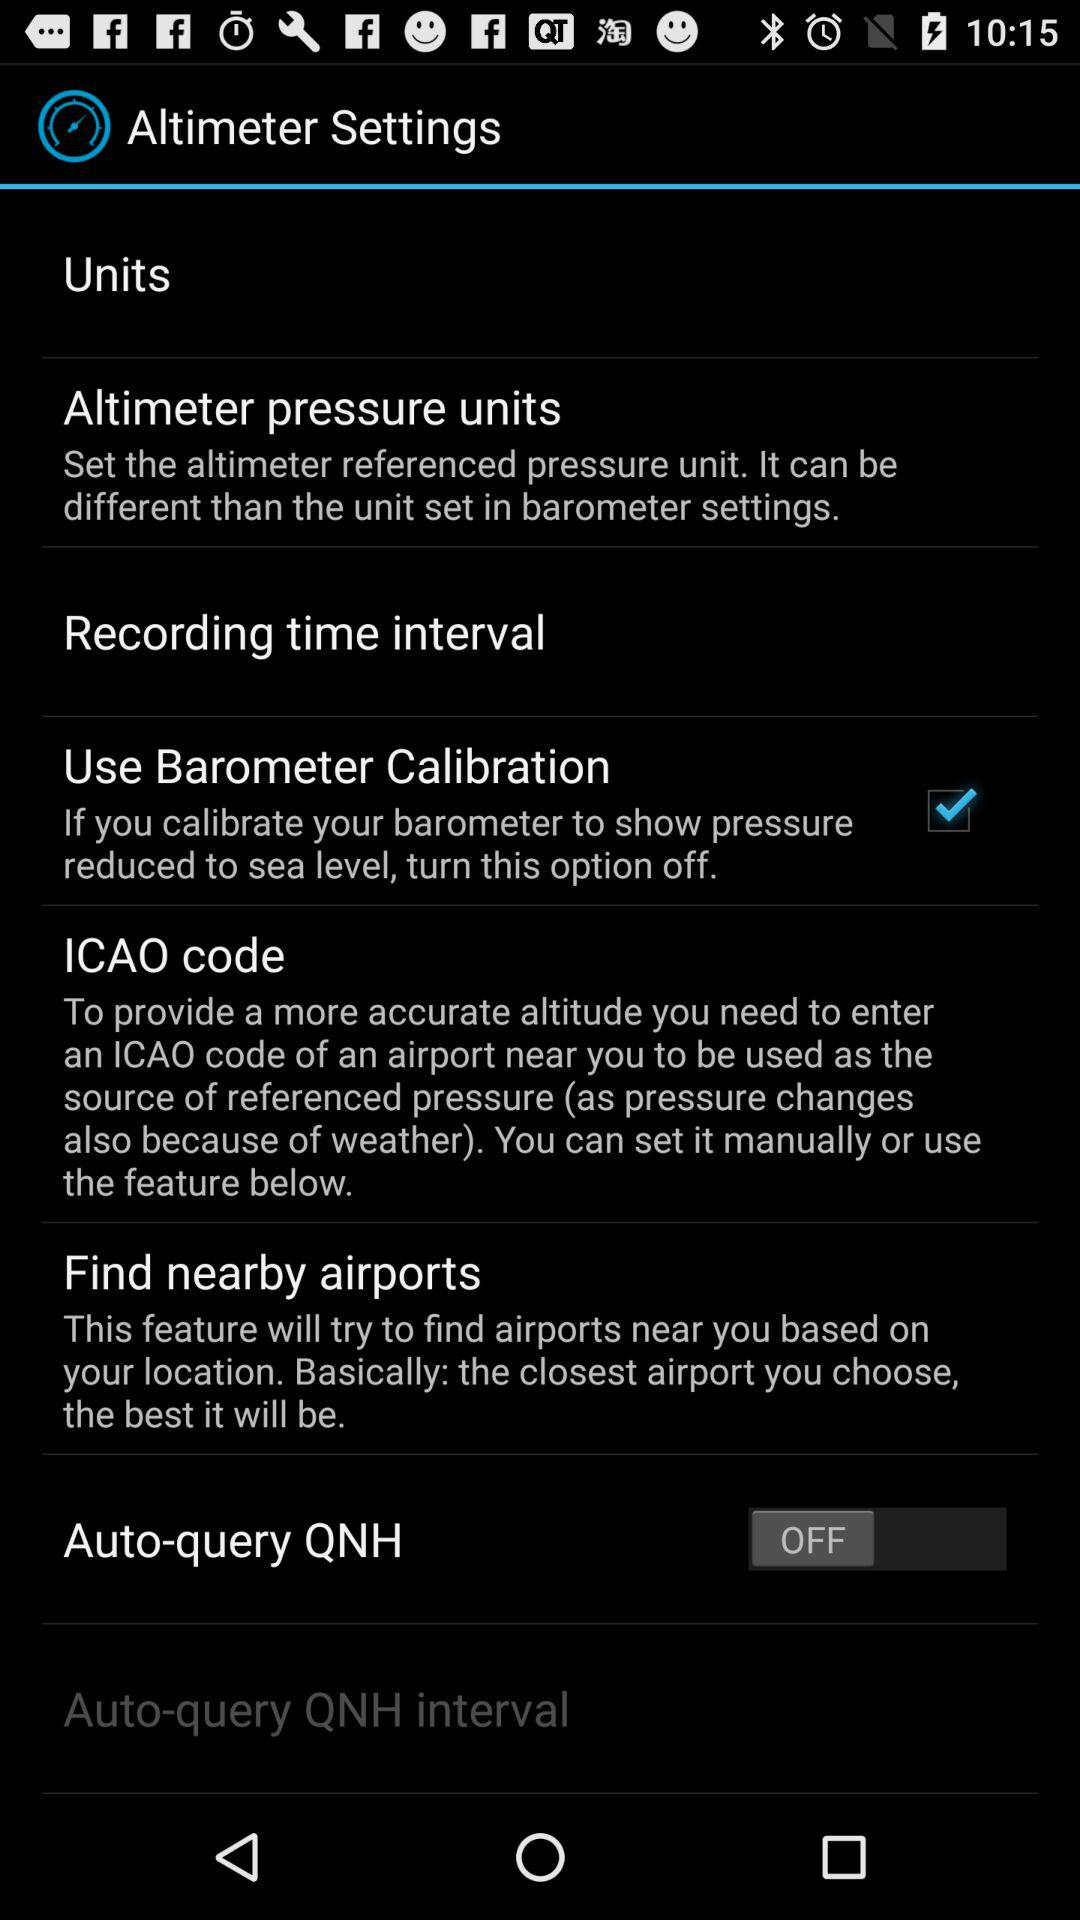What option is checked marked? The option that is checked marked is "Use Barometer Calibration". 